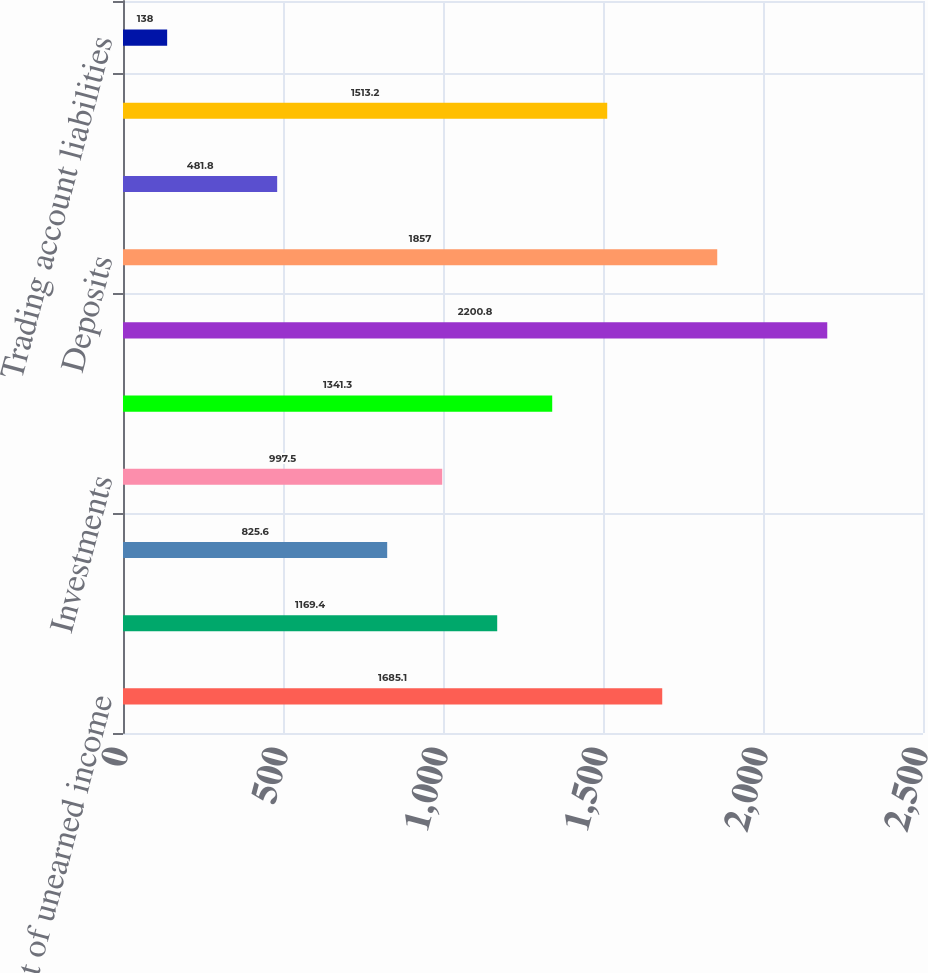Convert chart. <chart><loc_0><loc_0><loc_500><loc_500><bar_chart><fcel>Loans net of unearned income<fcel>Trading account assets<fcel>Federal funds sold and<fcel>Investments<fcel>Other assets<fcel>Total assets<fcel>Deposits<fcel>Federal funds purchased and<fcel>Short-term borrowings and<fcel>Trading account liabilities<nl><fcel>1685.1<fcel>1169.4<fcel>825.6<fcel>997.5<fcel>1341.3<fcel>2200.8<fcel>1857<fcel>481.8<fcel>1513.2<fcel>138<nl></chart> 